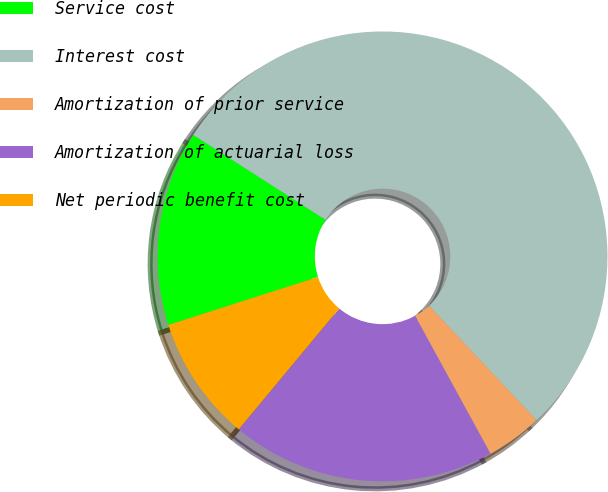<chart> <loc_0><loc_0><loc_500><loc_500><pie_chart><fcel>Service cost<fcel>Interest cost<fcel>Amortization of prior service<fcel>Amortization of actuarial loss<fcel>Net periodic benefit cost<nl><fcel>14.02%<fcel>53.91%<fcel>4.04%<fcel>19.0%<fcel>9.03%<nl></chart> 